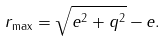Convert formula to latex. <formula><loc_0><loc_0><loc_500><loc_500>r _ { \max } = \sqrt { e ^ { 2 } + q ^ { 2 } } - e .</formula> 